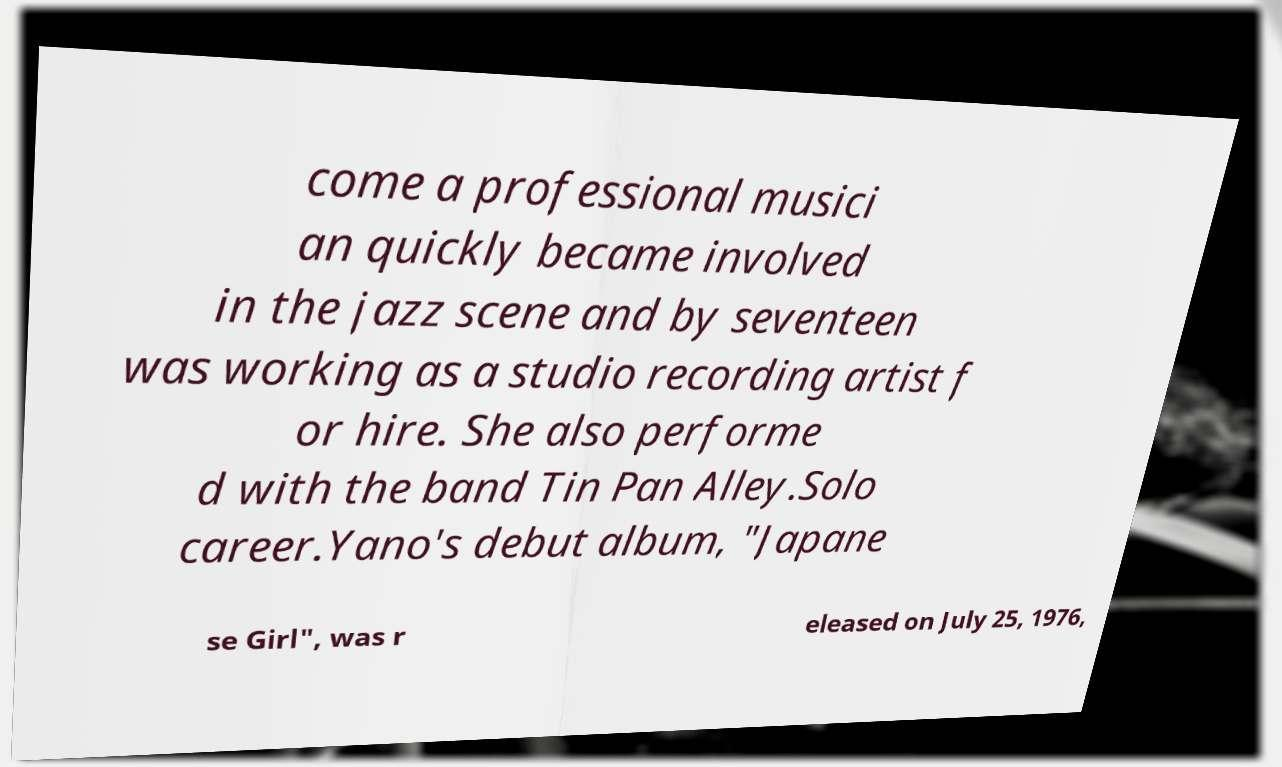I need the written content from this picture converted into text. Can you do that? come a professional musici an quickly became involved in the jazz scene and by seventeen was working as a studio recording artist f or hire. She also performe d with the band Tin Pan Alley.Solo career.Yano's debut album, "Japane se Girl", was r eleased on July 25, 1976, 